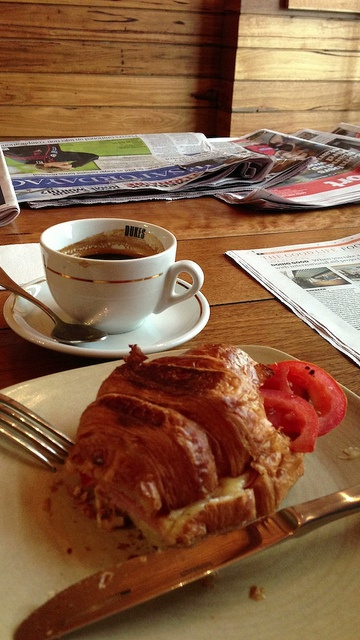Describe the objects in this image and their specific colors. I can see dining table in brown, maroon, ivory, and gray tones, sandwich in brown and maroon tones, cup in brown, gray, darkgray, and ivory tones, knife in brown and maroon tones, and fork in brown, maroon, and black tones in this image. 